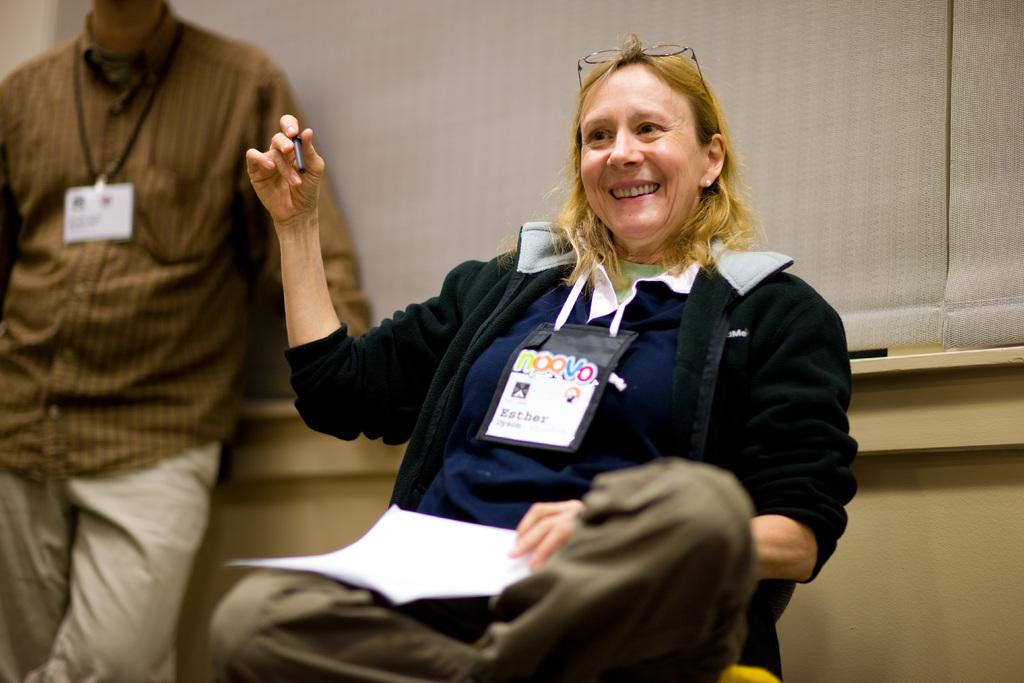What is the woman in the image doing? The woman is sitting in the image and holding a pen and paper. What accessories is the woman wearing? The woman is wearing glasses and a tag. Can you describe the background of the image? There is a person standing, a wall, and curtains in the background of the image. What type of cover is the woman using to protect herself from the gate in the image? There is no cover or gate present in the image. Can you tell me what the woman's uncle is doing in the background of the image? There is no uncle present in the image; only a person standing in the background. 